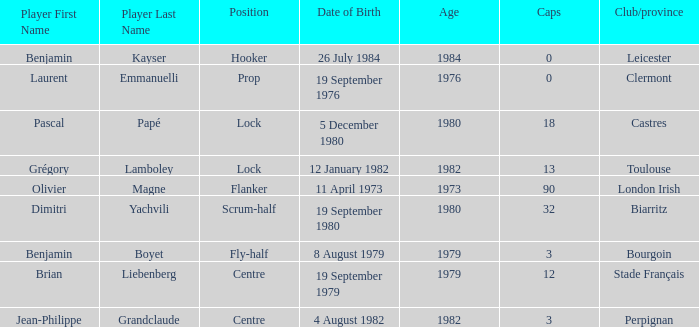What is the location of perpignan? Centre. 